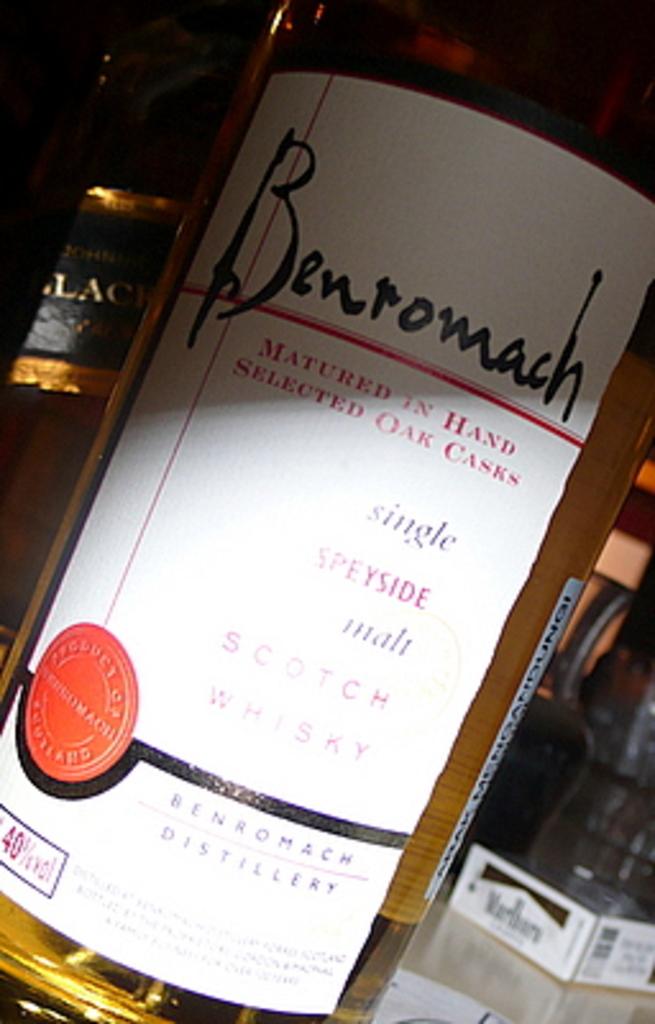What kind if wine is this?
Your response must be concise. Benromach. What proof alcohol is this?
Your answer should be very brief. 40. 